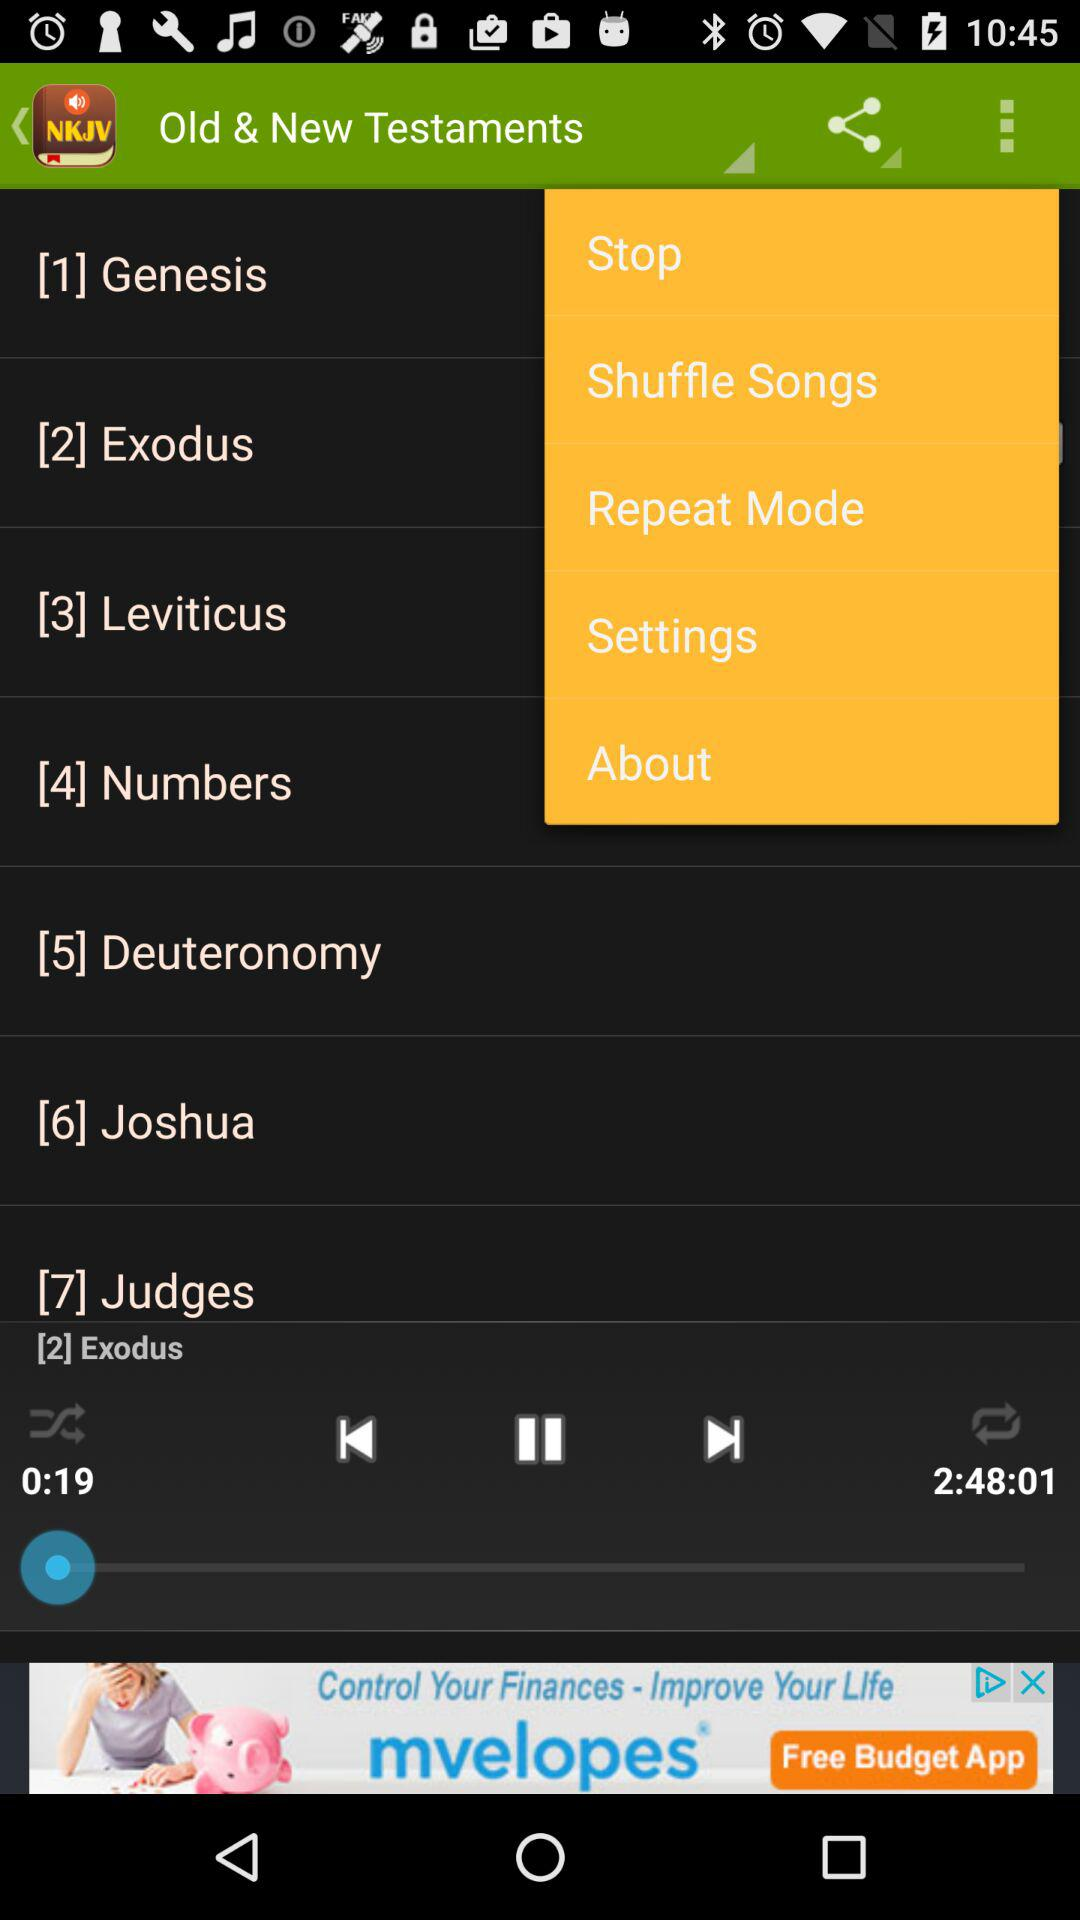Which audiobook is playing on the screen? The audiobook playing on the screen is "Exodus". 